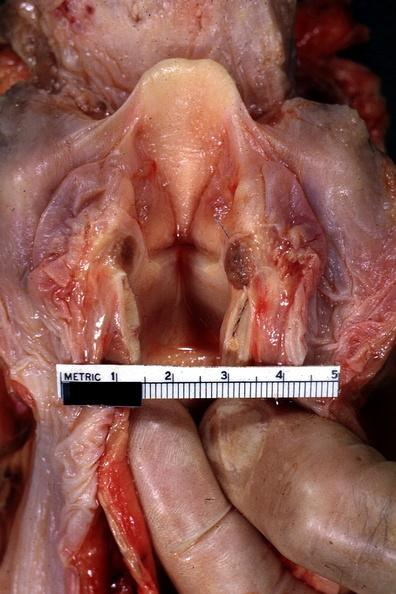s oral present?
Answer the question using a single word or phrase. Yes 